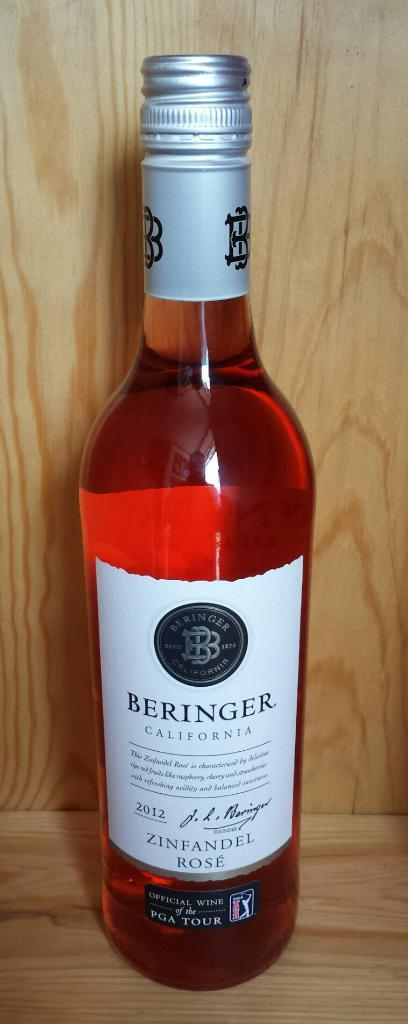<image>
Write a terse but informative summary of the picture. An unopened bottle of Zinfandel Rose produced by Beringer California. 